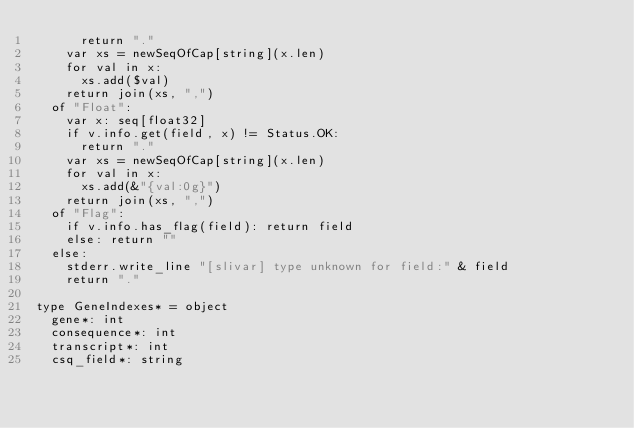<code> <loc_0><loc_0><loc_500><loc_500><_Nim_>      return "."
    var xs = newSeqOfCap[string](x.len)
    for val in x:
      xs.add($val)
    return join(xs, ",")
  of "Float":
    var x: seq[float32]
    if v.info.get(field, x) != Status.OK:
      return "."
    var xs = newSeqOfCap[string](x.len)
    for val in x:
      xs.add(&"{val:0g}")
    return join(xs, ",")
  of "Flag":
    if v.info.has_flag(field): return field
    else: return ""
  else:
    stderr.write_line "[slivar] type unknown for field:" & field
    return "."

type GeneIndexes* = object
  gene*: int
  consequence*: int
  transcript*: int
  csq_field*: string
</code> 